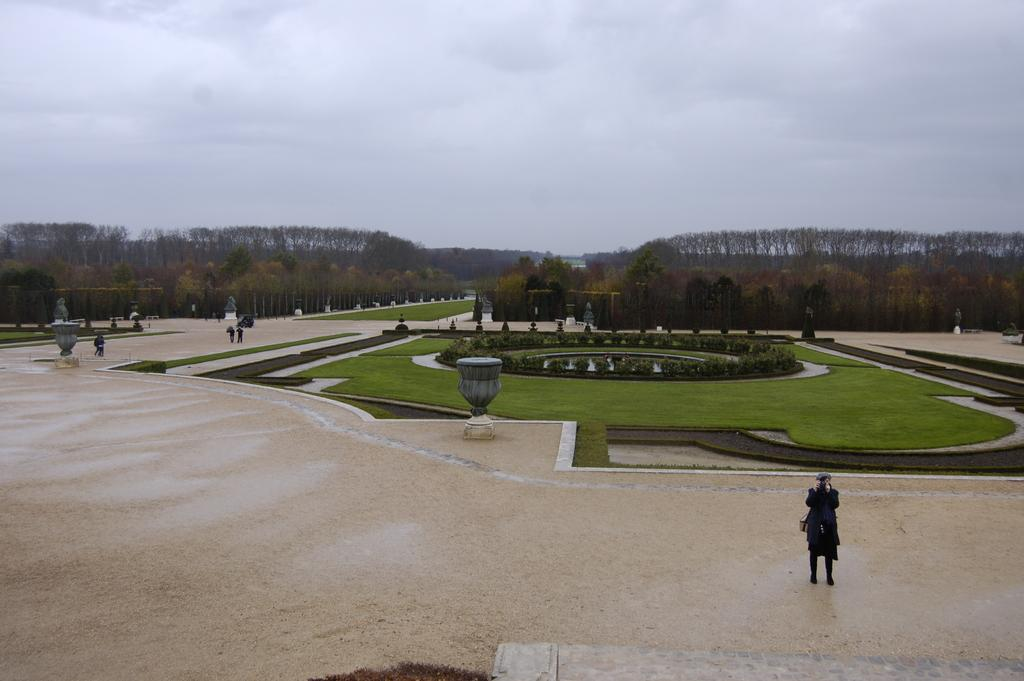What is in the foreground of the image? In the foreground of the image, there is grass, a fence, water, and a group of people on the road. What can be seen in the background of the image? In the background of the image, there are trees, poles, and the sky. What might be the location of the image based on the visible elements? The image might have been taken on the road, as there is a group of people on the road in the foreground. What type of disease is affecting the trees in the background of the image? There is no indication of any disease affecting the trees in the image; they appear to be healthy. What team is the robin cheering for in the image? There is no robin present in the image, so it is not possible to determine which team the robin might be cheering for. 